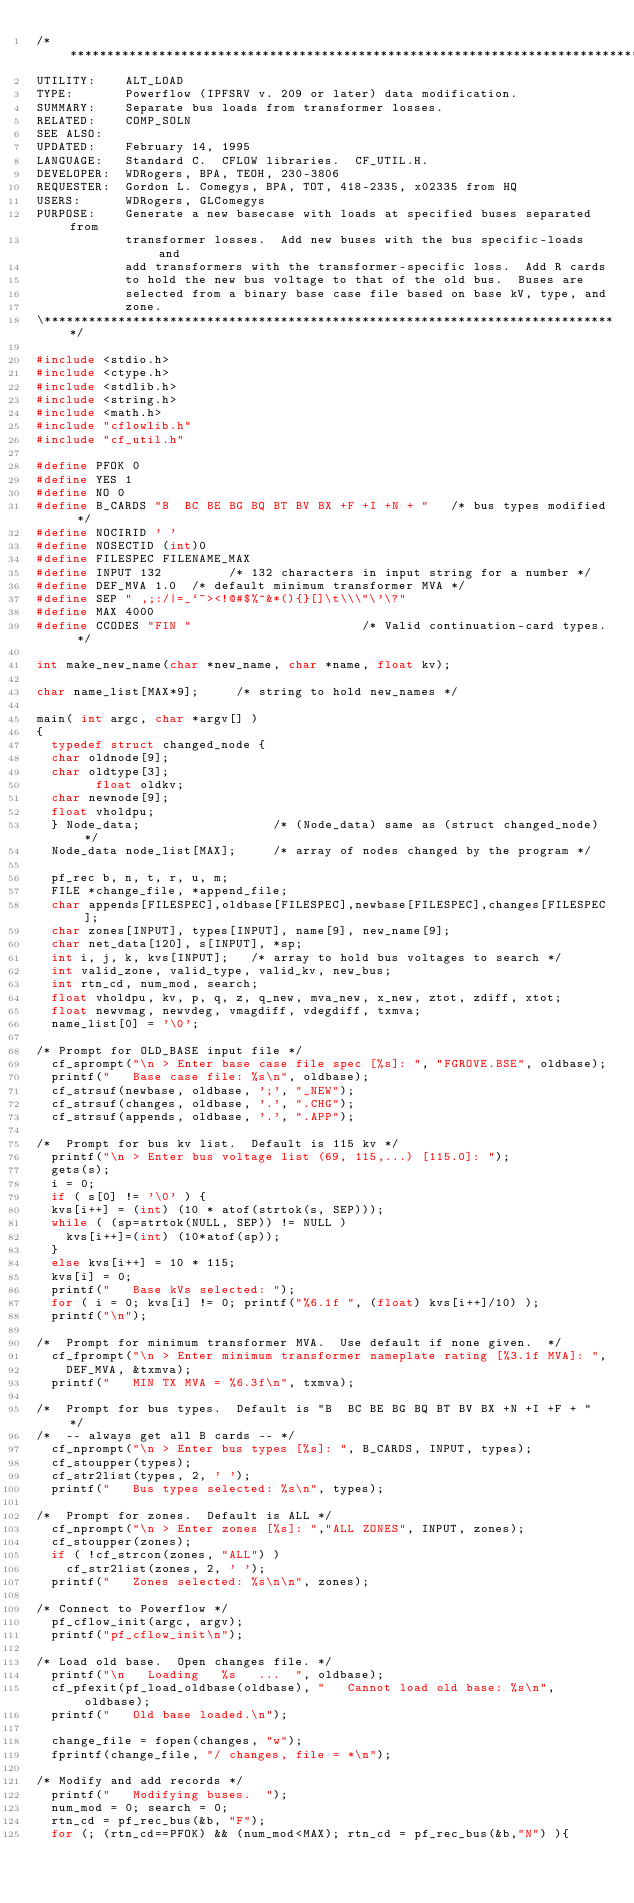<code> <loc_0><loc_0><loc_500><loc_500><_C_>/******************************************************************************\
UTILITY:    ALT_LOAD
TYPE:       Powerflow (IPFSRV v. 209 or later) data modification.
SUMMARY:    Separate bus loads from transformer losses.
RELATED:    COMP_SOLN
SEE ALSO:
UPDATED:    February 14, 1995
LANGUAGE:   Standard C.  CFLOW libraries.  CF_UTIL.H.
DEVELOPER:  WDRogers, BPA, TEOH, 230-3806
REQUESTER:  Gordon L. Comegys, BPA, TOT, 418-2335, x02335 from HQ
USERS:      WDRogers, GLComegys
PURPOSE:    Generate a new basecase with loads at specified buses separated from
            transformer losses.  Add new buses with the bus specific-loads and
            add transformers with the transformer-specific loss.  Add R cards
            to hold the new bus voltage to that of the old bus.  Buses are 
            selected from a binary base case file based on base kV, type, and
            zone.
\******************************************************************************/

#include <stdio.h>
#include <ctype.h>
#include <stdlib.h>
#include <string.h>
#include <math.h>
#include "cflowlib.h"
#include "cf_util.h"

#define PFOK 0
#define YES 1
#define NO 0
#define B_CARDS "B  BC BE BG BQ BT BV BX +F +I +N + "   /* bus types modified */
#define NOCIRID ' '
#define NOSECTID (int)0
#define FILESPEC FILENAME_MAX
#define INPUT 132         /* 132 characters in input string for a number */
#define DEF_MVA 1.0  /* default minimum transformer MVA */
#define SEP " ,;:/|=_`~><!@#$%^&*(){}[]\t\\\"\'\?"
#define MAX 4000
#define CCODES "FIN "                       /* Valid continuation-card types. */

int make_new_name(char *new_name, char *name, float kv);

char name_list[MAX*9];     /* string to hold new_names */

main( int argc, char *argv[] )
{
  typedef struct changed_node {
	char oldnode[9];
	char oldtype[3];
        float oldkv;
	char newnode[9];
	float vholdpu;
  } Node_data;                  /* (Node_data) same as (struct changed_node) */
  Node_data node_list[MAX];     /* array of nodes changed by the program */

  pf_rec b, n, t, r, u, m;
  FILE *change_file, *append_file;
  char appends[FILESPEC],oldbase[FILESPEC],newbase[FILESPEC],changes[FILESPEC];
  char zones[INPUT], types[INPUT], name[9], new_name[9];
  char net_data[120], s[INPUT], *sp;
  int i, j, k, kvs[INPUT];   /* array to hold bus voltages to search */
  int valid_zone, valid_type, valid_kv, new_bus;
  int rtn_cd, num_mod, search;
  float vholdpu, kv, p, q, z, q_new, mva_new, x_new, ztot, zdiff, xtot;
  float newvmag, newvdeg, vmagdiff, vdegdiff, txmva;
  name_list[0] = '\0';

/* Prompt for OLD_BASE input file */
  cf_sprompt("\n > Enter base case file spec [%s]: ", "FGROVE.BSE", oldbase);
  printf("   Base case file: %s\n", oldbase);
  cf_strsuf(newbase, oldbase, ';', "_NEW");
  cf_strsuf(changes, oldbase, '.', ".CHG");
  cf_strsuf(appends, oldbase, '.', ".APP");

/*  Prompt for bus kv list.  Default is 115 kv */
  printf("\n > Enter bus voltage list (69, 115,...) [115.0]: ");
  gets(s);
  i = 0;
  if ( s[0] != '\0' ) {
	kvs[i++] = (int) (10 * atof(strtok(s, SEP)));
	while ( (sp=strtok(NULL, SEP)) != NULL )
		kvs[i++]=(int) (10*atof(sp));
  }
  else kvs[i++] = 10 * 115;
  kvs[i] = 0;
  printf("   Base kVs selected: ");
  for ( i = 0; kvs[i] != 0; printf("%6.1f ", (float) kvs[i++]/10) );
  printf("\n");

/*  Prompt for minimum transformer MVA.  Use default if none given.  */
  cf_fprompt("\n > Enter minimum transformer nameplate rating [%3.1f MVA]: ",
    DEF_MVA, &txmva);
  printf("   MIN TX MVA = %6.3f\n", txmva);

/*  Prompt for bus types.  Default is "B  BC BE BG BQ BT BV BX +N +I +F + " */
/*  -- always get all B cards -- */
  cf_nprompt("\n > Enter bus types [%s]: ", B_CARDS, INPUT, types);
  cf_stoupper(types);
  cf_str2list(types, 2, ' ');
  printf("   Bus types selected: %s\n", types);

/*  Prompt for zones.  Default is ALL */
  cf_nprompt("\n > Enter zones [%s]: ","ALL ZONES", INPUT, zones);
  cf_stoupper(zones);
  if ( !cf_strcon(zones, "ALL") )
  	cf_str2list(zones, 2, ' ');
  printf("   Zones selected: %s\n\n", zones);

/* Connect to Powerflow */
  pf_cflow_init(argc, argv);
  printf("pf_cflow_init\n");

/* Load old base.  Open changes file. */
  printf("\n   Loading   %s   ...  ", oldbase);
  cf_pfexit(pf_load_oldbase(oldbase), "   Cannot load old base: %s\n", oldbase);
  printf("   Old base loaded.\n");

  change_file = fopen(changes, "w");
  fprintf(change_file, "/ changes, file = *\n");

/* Modify and add records */
  printf("   Modifying buses.  ");
  num_mod = 0; search = 0;
  rtn_cd = pf_rec_bus(&b, "F");
  for (; (rtn_cd==PFOK) && (num_mod<MAX); rtn_cd = pf_rec_bus(&b,"N") ){</code> 